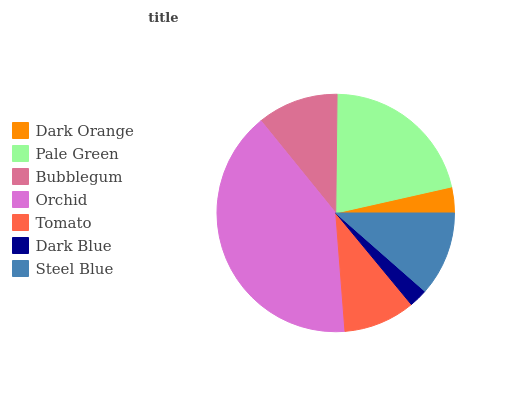Is Dark Blue the minimum?
Answer yes or no. Yes. Is Orchid the maximum?
Answer yes or no. Yes. Is Pale Green the minimum?
Answer yes or no. No. Is Pale Green the maximum?
Answer yes or no. No. Is Pale Green greater than Dark Orange?
Answer yes or no. Yes. Is Dark Orange less than Pale Green?
Answer yes or no. Yes. Is Dark Orange greater than Pale Green?
Answer yes or no. No. Is Pale Green less than Dark Orange?
Answer yes or no. No. Is Bubblegum the high median?
Answer yes or no. Yes. Is Bubblegum the low median?
Answer yes or no. Yes. Is Steel Blue the high median?
Answer yes or no. No. Is Tomato the low median?
Answer yes or no. No. 